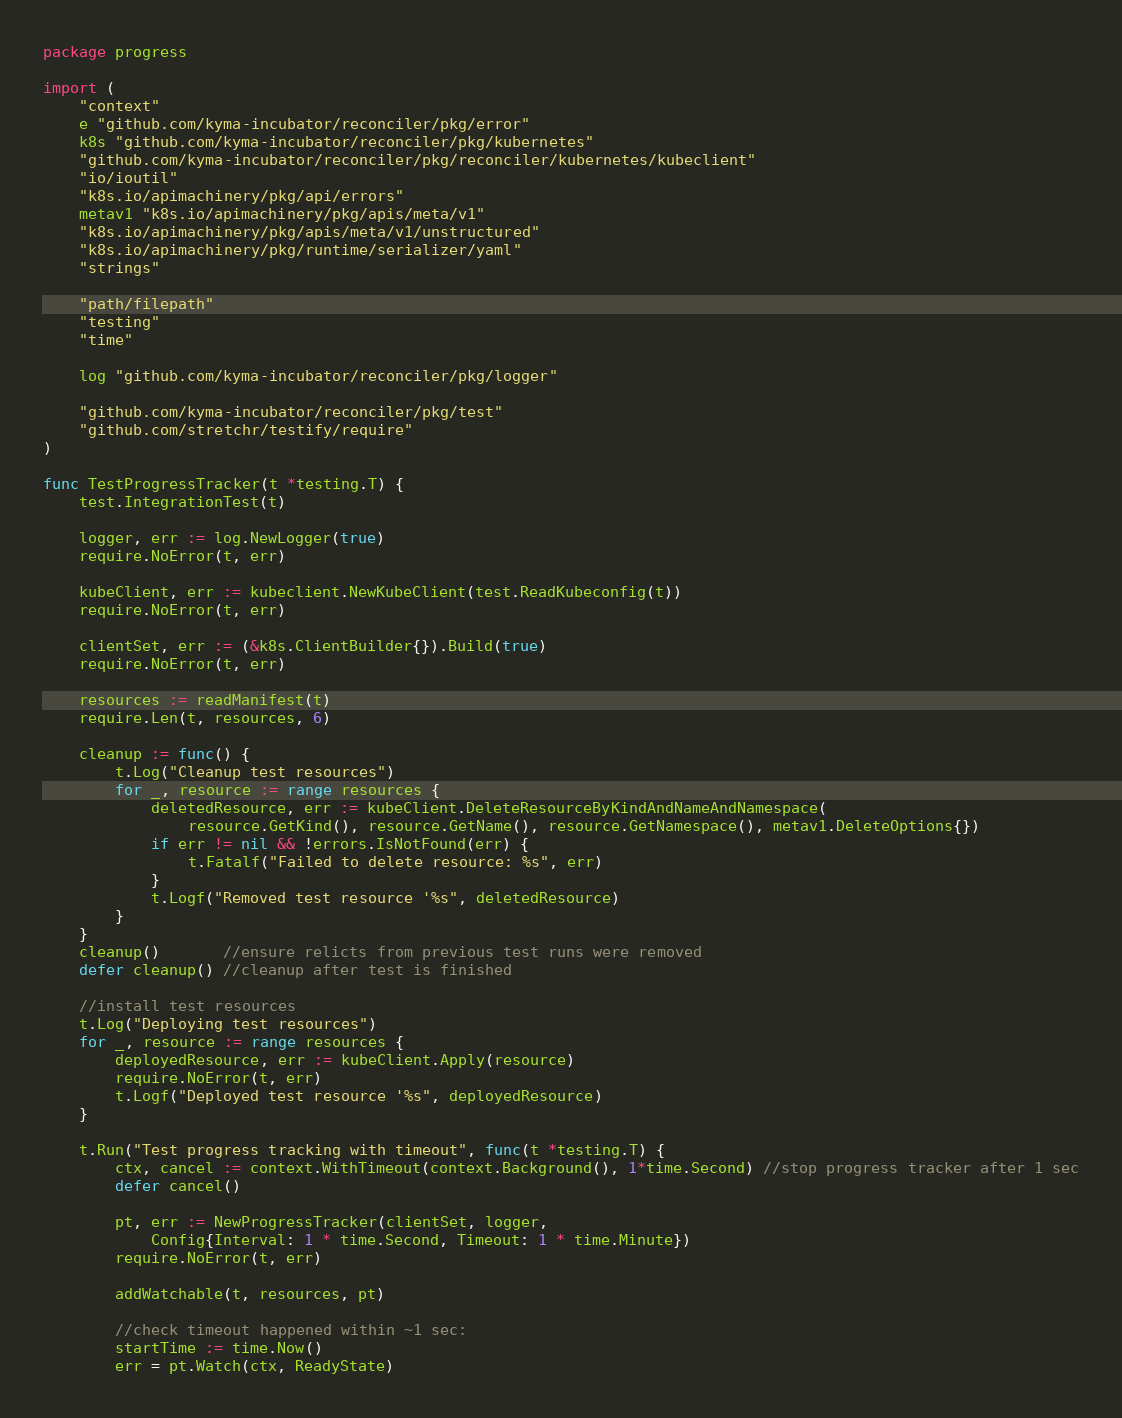<code> <loc_0><loc_0><loc_500><loc_500><_Go_>package progress

import (
	"context"
	e "github.com/kyma-incubator/reconciler/pkg/error"
	k8s "github.com/kyma-incubator/reconciler/pkg/kubernetes"
	"github.com/kyma-incubator/reconciler/pkg/reconciler/kubernetes/kubeclient"
	"io/ioutil"
	"k8s.io/apimachinery/pkg/api/errors"
	metav1 "k8s.io/apimachinery/pkg/apis/meta/v1"
	"k8s.io/apimachinery/pkg/apis/meta/v1/unstructured"
	"k8s.io/apimachinery/pkg/runtime/serializer/yaml"
	"strings"

	"path/filepath"
	"testing"
	"time"

	log "github.com/kyma-incubator/reconciler/pkg/logger"

	"github.com/kyma-incubator/reconciler/pkg/test"
	"github.com/stretchr/testify/require"
)

func TestProgressTracker(t *testing.T) {
	test.IntegrationTest(t)

	logger, err := log.NewLogger(true)
	require.NoError(t, err)

	kubeClient, err := kubeclient.NewKubeClient(test.ReadKubeconfig(t))
	require.NoError(t, err)

	clientSet, err := (&k8s.ClientBuilder{}).Build(true)
	require.NoError(t, err)

	resources := readManifest(t)
	require.Len(t, resources, 6)

	cleanup := func() {
		t.Log("Cleanup test resources")
		for _, resource := range resources {
			deletedResource, err := kubeClient.DeleteResourceByKindAndNameAndNamespace(
				resource.GetKind(), resource.GetName(), resource.GetNamespace(), metav1.DeleteOptions{})
			if err != nil && !errors.IsNotFound(err) {
				t.Fatalf("Failed to delete resource: %s", err)
			}
			t.Logf("Removed test resource '%s", deletedResource)
		}
	}
	cleanup()       //ensure relicts from previous test runs were removed
	defer cleanup() //cleanup after test is finished

	//install test resources
	t.Log("Deploying test resources")
	for _, resource := range resources {
		deployedResource, err := kubeClient.Apply(resource)
		require.NoError(t, err)
		t.Logf("Deployed test resource '%s", deployedResource)
	}

	t.Run("Test progress tracking with timeout", func(t *testing.T) {
		ctx, cancel := context.WithTimeout(context.Background(), 1*time.Second) //stop progress tracker after 1 sec
		defer cancel()

		pt, err := NewProgressTracker(clientSet, logger,
			Config{Interval: 1 * time.Second, Timeout: 1 * time.Minute})
		require.NoError(t, err)

		addWatchable(t, resources, pt)

		//check timeout happened within ~1 sec:
		startTime := time.Now()
		err = pt.Watch(ctx, ReadyState)</code> 